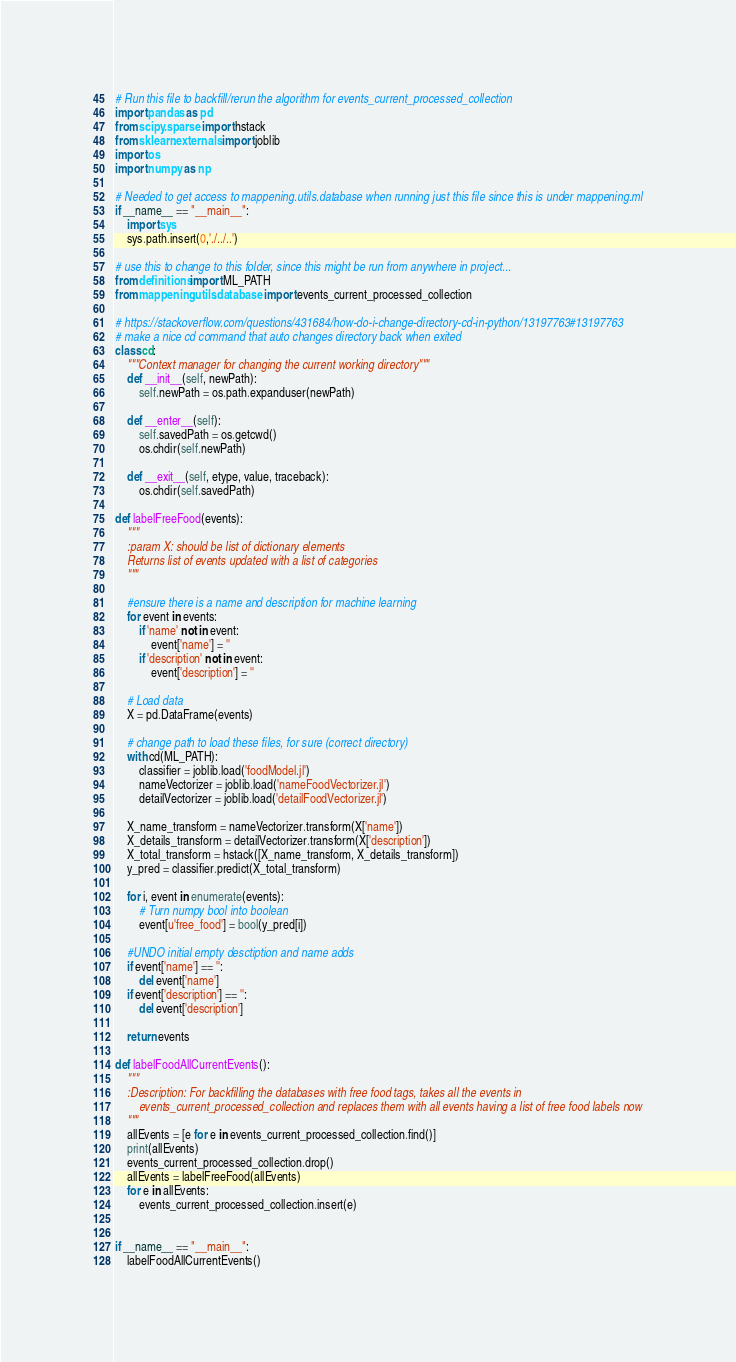Convert code to text. <code><loc_0><loc_0><loc_500><loc_500><_Python_># Run this file to backfill/rerun the algorithm for events_current_processed_collection
import pandas as pd
from scipy.sparse import hstack
from sklearn.externals import joblib 
import os
import numpy as np

# Needed to get access to mappening.utils.database when running just this file since this is under mappening.ml
if __name__ == "__main__":
    import sys
    sys.path.insert(0,'./../..')
    
# use this to change to this folder, since this might be run from anywhere in project...
from definitions import ML_PATH
from mappening.utils.database import events_current_processed_collection

# https://stackoverflow.com/questions/431684/how-do-i-change-directory-cd-in-python/13197763#13197763
# make a nice cd command that auto changes directory back when exited
class cd:
    """Context manager for changing the current working directory"""
    def __init__(self, newPath):
        self.newPath = os.path.expanduser(newPath)

    def __enter__(self):
        self.savedPath = os.getcwd()
        os.chdir(self.newPath)

    def __exit__(self, etype, value, traceback):
        os.chdir(self.savedPath)
        
def labelFreeFood(events):
    """
    :param X: should be list of dictionary elements
    Returns list of events updated with a list of categories
    """

    #ensure there is a name and description for machine learning
    for event in events:
        if 'name' not in event:
            event['name'] = ''
        if 'description' not in event:
            event['description'] = ''

    # Load data
    X = pd.DataFrame(events)

    # change path to load these files, for sure (correct directory)
    with cd(ML_PATH):
        classifier = joblib.load('foodModel.jl')
        nameVectorizer = joblib.load('nameFoodVectorizer.jl')
        detailVectorizer = joblib.load('detailFoodVectorizer.jl')

    X_name_transform = nameVectorizer.transform(X['name'])
    X_details_transform = detailVectorizer.transform(X['description'])
    X_total_transform = hstack([X_name_transform, X_details_transform])
    y_pred = classifier.predict(X_total_transform)

    for i, event in enumerate(events):
        # Turn numpy bool into boolean 
        event[u'free_food'] = bool(y_pred[i])
        
    #UNDO initial empty desctiption and name adds
    if event['name'] == '':
        del event['name']
    if event['description'] == '':
        del event['description']

    return events

def labelFoodAllCurrentEvents():
    """
    :Description: For backfilling the databases with free food tags, takes all the events in 
        events_current_processed_collection and replaces them with all events having a list of free food labels now
    """
    allEvents = [e for e in events_current_processed_collection.find()]
    print(allEvents)
    events_current_processed_collection.drop()
    allEvents = labelFreeFood(allEvents)
    for e in allEvents:
        events_current_processed_collection.insert(e)


if __name__ == "__main__":
    labelFoodAllCurrentEvents()
</code> 